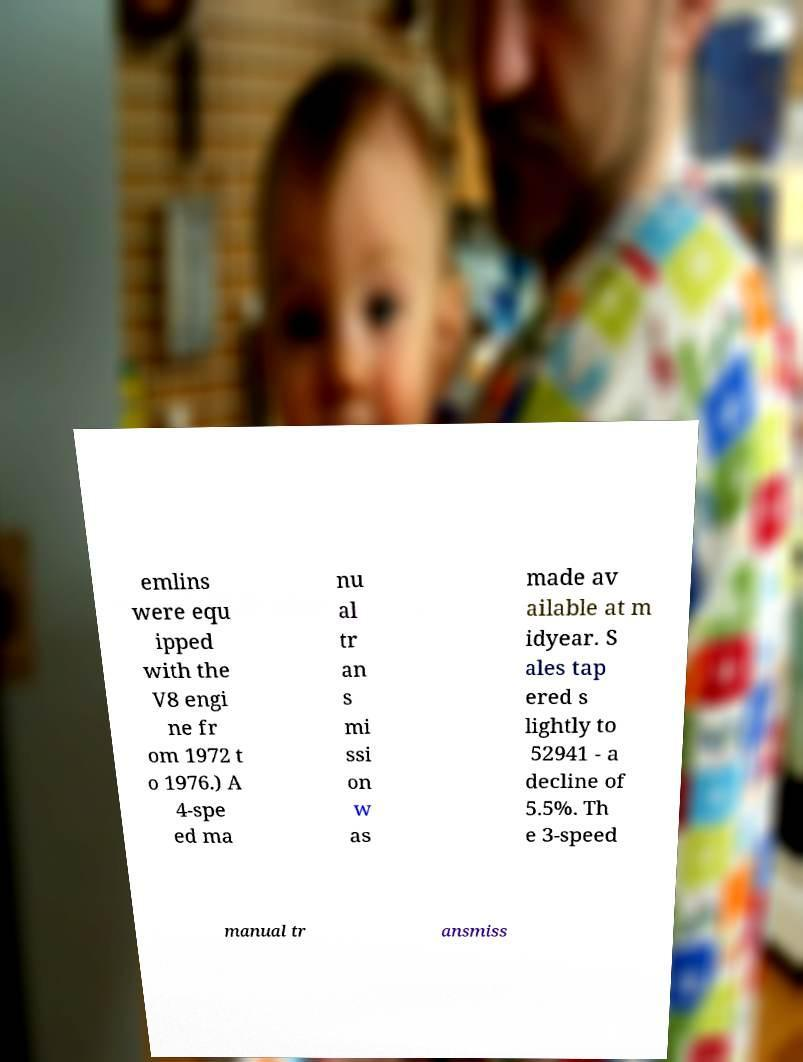What messages or text are displayed in this image? I need them in a readable, typed format. emlins were equ ipped with the V8 engi ne fr om 1972 t o 1976.) A 4-spe ed ma nu al tr an s mi ssi on w as made av ailable at m idyear. S ales tap ered s lightly to 52941 - a decline of 5.5%. Th e 3-speed manual tr ansmiss 